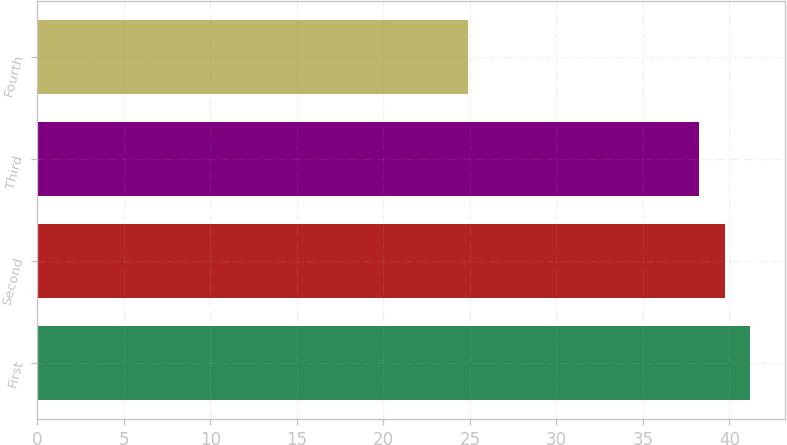<chart> <loc_0><loc_0><loc_500><loc_500><bar_chart><fcel>First<fcel>Second<fcel>Third<fcel>Fourth<nl><fcel>41.19<fcel>39.73<fcel>38.27<fcel>24.9<nl></chart> 